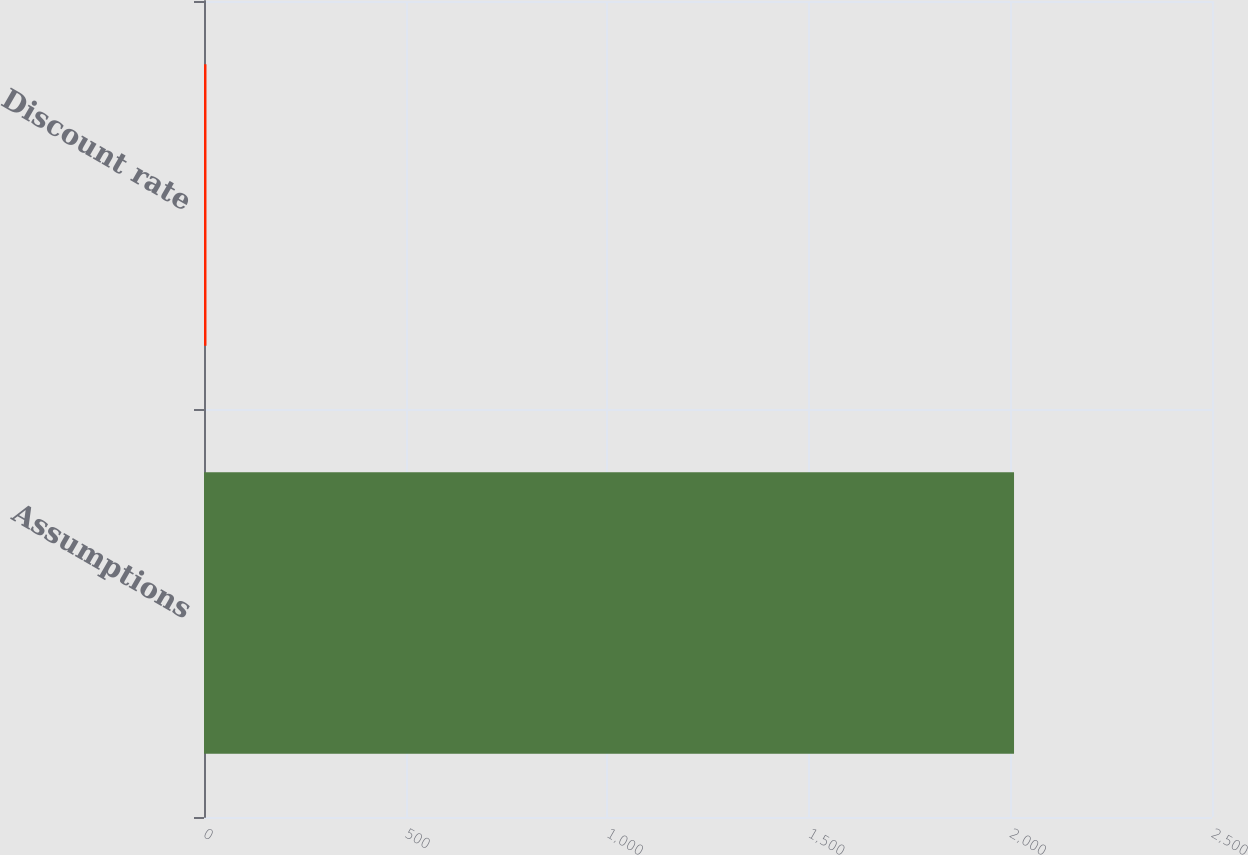Convert chart. <chart><loc_0><loc_0><loc_500><loc_500><bar_chart><fcel>Assumptions<fcel>Discount rate<nl><fcel>2009<fcel>6.14<nl></chart> 